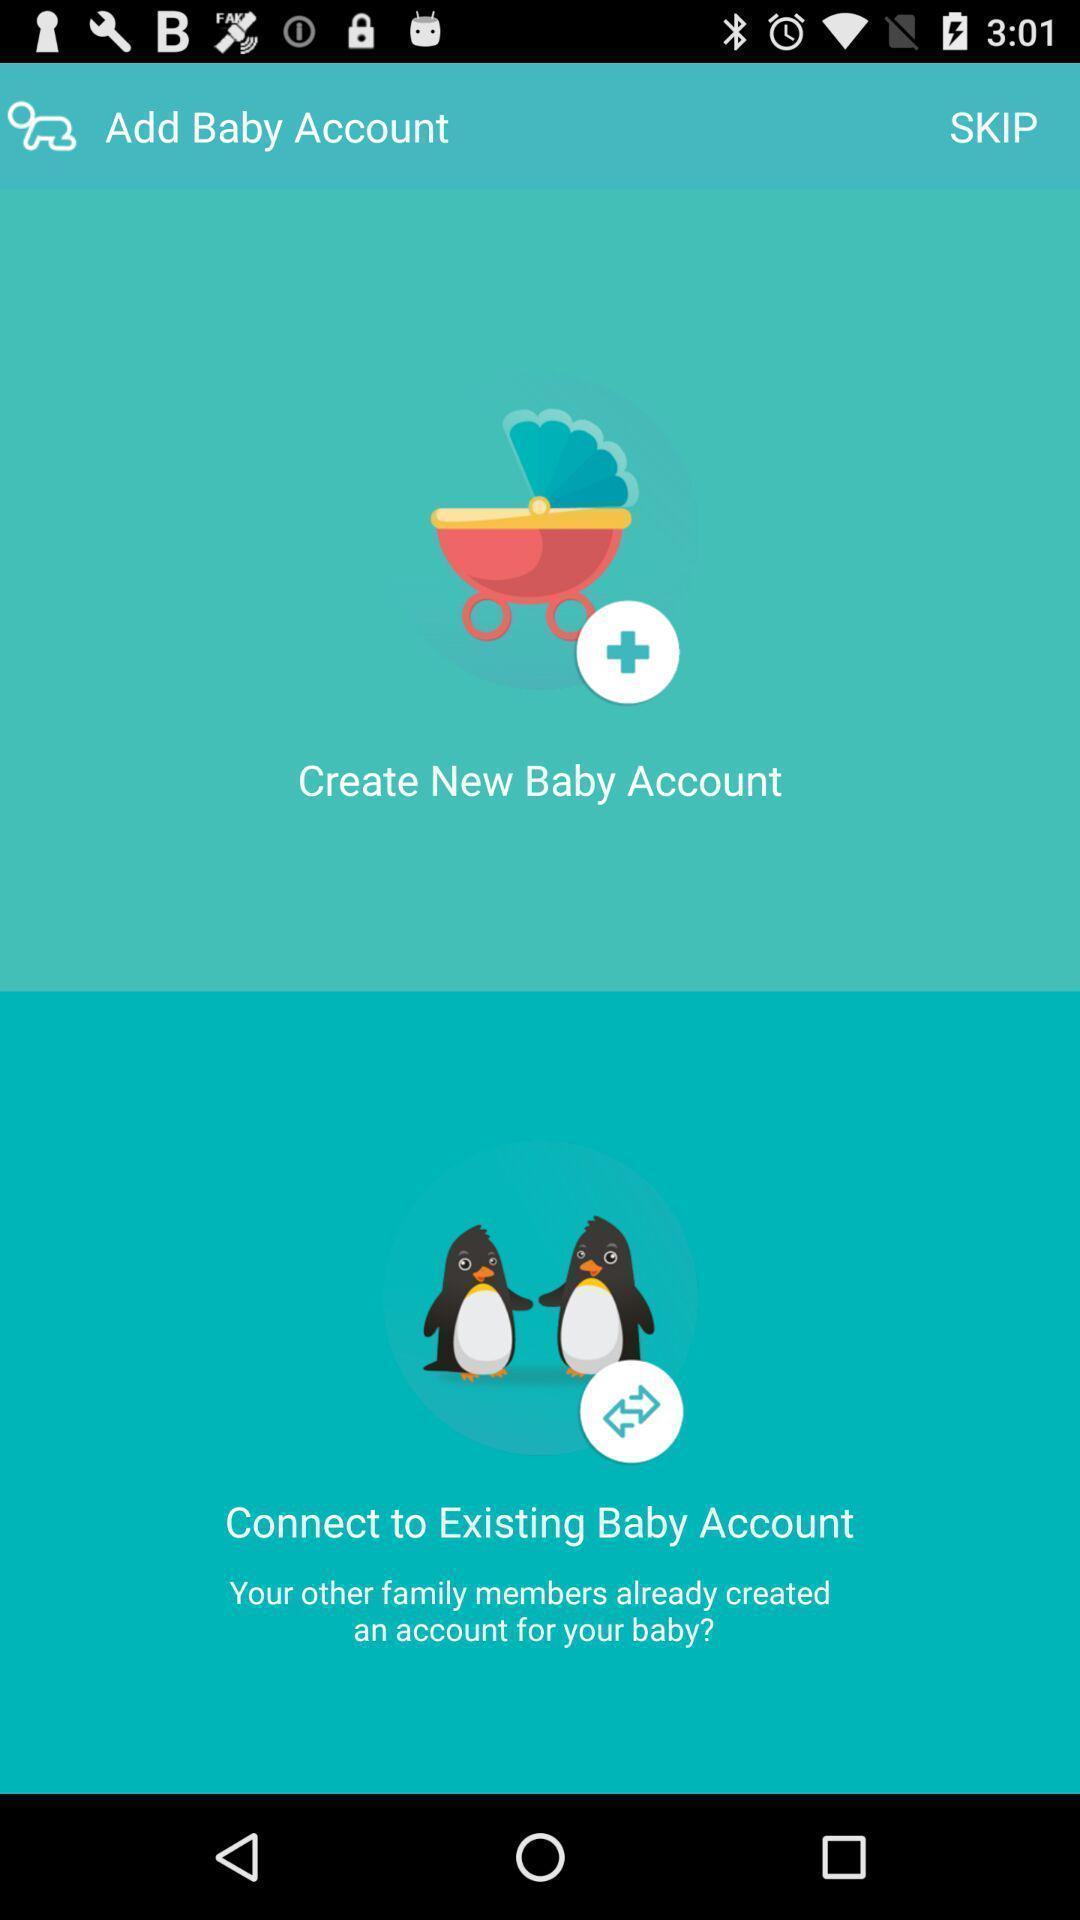Describe the visual elements of this screenshot. Page displaying to create new baby account in app. 